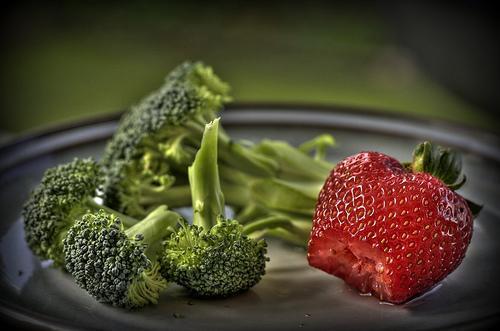How many strawberries are there?
Give a very brief answer. 1. 